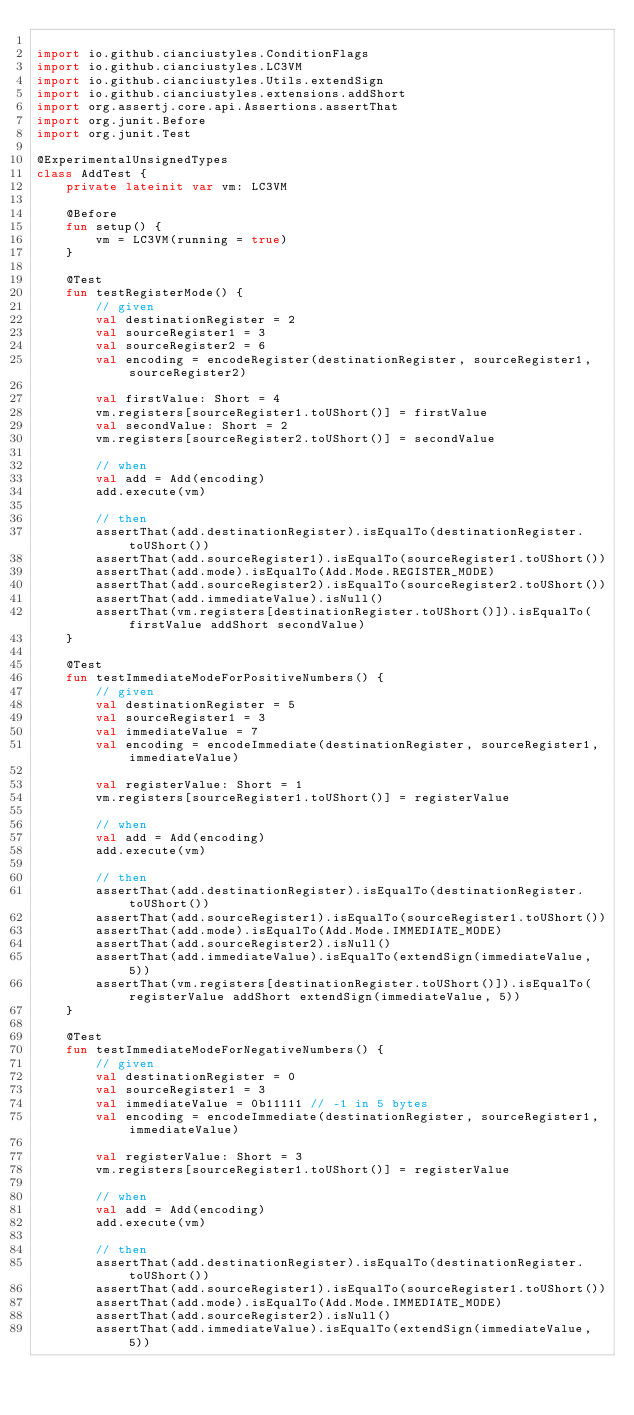Convert code to text. <code><loc_0><loc_0><loc_500><loc_500><_Kotlin_>
import io.github.cianciustyles.ConditionFlags
import io.github.cianciustyles.LC3VM
import io.github.cianciustyles.Utils.extendSign
import io.github.cianciustyles.extensions.addShort
import org.assertj.core.api.Assertions.assertThat
import org.junit.Before
import org.junit.Test

@ExperimentalUnsignedTypes
class AddTest {
    private lateinit var vm: LC3VM

    @Before
    fun setup() {
        vm = LC3VM(running = true)
    }

    @Test
    fun testRegisterMode() {
        // given
        val destinationRegister = 2
        val sourceRegister1 = 3
        val sourceRegister2 = 6
        val encoding = encodeRegister(destinationRegister, sourceRegister1, sourceRegister2)

        val firstValue: Short = 4
        vm.registers[sourceRegister1.toUShort()] = firstValue
        val secondValue: Short = 2
        vm.registers[sourceRegister2.toUShort()] = secondValue

        // when
        val add = Add(encoding)
        add.execute(vm)

        // then
        assertThat(add.destinationRegister).isEqualTo(destinationRegister.toUShort())
        assertThat(add.sourceRegister1).isEqualTo(sourceRegister1.toUShort())
        assertThat(add.mode).isEqualTo(Add.Mode.REGISTER_MODE)
        assertThat(add.sourceRegister2).isEqualTo(sourceRegister2.toUShort())
        assertThat(add.immediateValue).isNull()
        assertThat(vm.registers[destinationRegister.toUShort()]).isEqualTo(firstValue addShort secondValue)
    }

    @Test
    fun testImmediateModeForPositiveNumbers() {
        // given
        val destinationRegister = 5
        val sourceRegister1 = 3
        val immediateValue = 7
        val encoding = encodeImmediate(destinationRegister, sourceRegister1, immediateValue)

        val registerValue: Short = 1
        vm.registers[sourceRegister1.toUShort()] = registerValue

        // when
        val add = Add(encoding)
        add.execute(vm)

        // then
        assertThat(add.destinationRegister).isEqualTo(destinationRegister.toUShort())
        assertThat(add.sourceRegister1).isEqualTo(sourceRegister1.toUShort())
        assertThat(add.mode).isEqualTo(Add.Mode.IMMEDIATE_MODE)
        assertThat(add.sourceRegister2).isNull()
        assertThat(add.immediateValue).isEqualTo(extendSign(immediateValue, 5))
        assertThat(vm.registers[destinationRegister.toUShort()]).isEqualTo(registerValue addShort extendSign(immediateValue, 5))
    }

    @Test
    fun testImmediateModeForNegativeNumbers() {
        // given
        val destinationRegister = 0
        val sourceRegister1 = 3
        val immediateValue = 0b11111 // -1 in 5 bytes
        val encoding = encodeImmediate(destinationRegister, sourceRegister1, immediateValue)

        val registerValue: Short = 3
        vm.registers[sourceRegister1.toUShort()] = registerValue

        // when
        val add = Add(encoding)
        add.execute(vm)

        // then
        assertThat(add.destinationRegister).isEqualTo(destinationRegister.toUShort())
        assertThat(add.sourceRegister1).isEqualTo(sourceRegister1.toUShort())
        assertThat(add.mode).isEqualTo(Add.Mode.IMMEDIATE_MODE)
        assertThat(add.sourceRegister2).isNull()
        assertThat(add.immediateValue).isEqualTo(extendSign(immediateValue, 5))</code> 